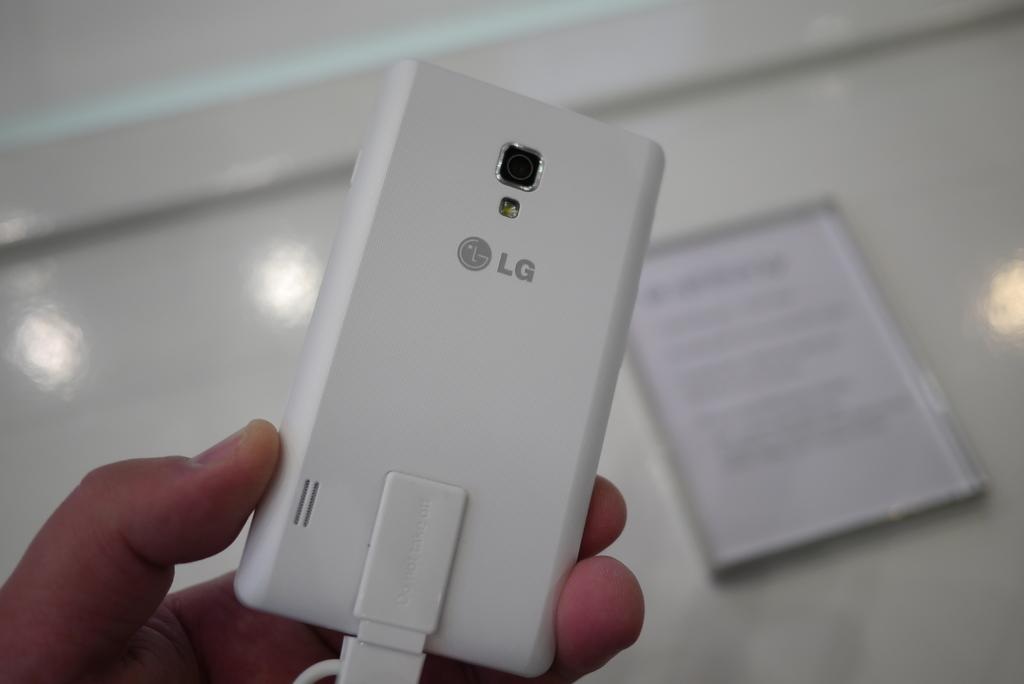<image>
Summarize the visual content of the image. a person holding a white LG phone connected with a USB cord 